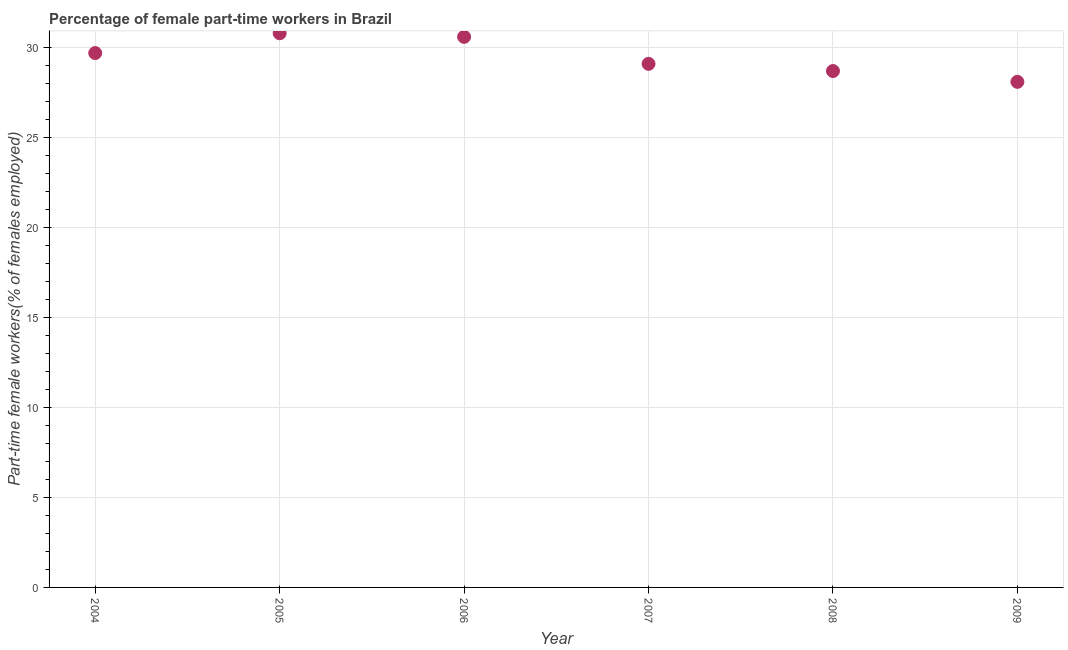What is the percentage of part-time female workers in 2009?
Provide a succinct answer. 28.1. Across all years, what is the maximum percentage of part-time female workers?
Ensure brevity in your answer.  30.8. Across all years, what is the minimum percentage of part-time female workers?
Your answer should be very brief. 28.1. In which year was the percentage of part-time female workers minimum?
Ensure brevity in your answer.  2009. What is the sum of the percentage of part-time female workers?
Your answer should be compact. 177. What is the difference between the percentage of part-time female workers in 2004 and 2005?
Offer a very short reply. -1.1. What is the average percentage of part-time female workers per year?
Give a very brief answer. 29.5. What is the median percentage of part-time female workers?
Keep it short and to the point. 29.4. In how many years, is the percentage of part-time female workers greater than 12 %?
Your answer should be very brief. 6. What is the ratio of the percentage of part-time female workers in 2006 to that in 2008?
Give a very brief answer. 1.07. What is the difference between the highest and the second highest percentage of part-time female workers?
Offer a terse response. 0.2. Is the sum of the percentage of part-time female workers in 2004 and 2009 greater than the maximum percentage of part-time female workers across all years?
Give a very brief answer. Yes. What is the difference between the highest and the lowest percentage of part-time female workers?
Provide a succinct answer. 2.7. In how many years, is the percentage of part-time female workers greater than the average percentage of part-time female workers taken over all years?
Offer a very short reply. 3. Does the graph contain any zero values?
Ensure brevity in your answer.  No. Does the graph contain grids?
Your answer should be very brief. Yes. What is the title of the graph?
Offer a terse response. Percentage of female part-time workers in Brazil. What is the label or title of the X-axis?
Your answer should be compact. Year. What is the label or title of the Y-axis?
Provide a succinct answer. Part-time female workers(% of females employed). What is the Part-time female workers(% of females employed) in 2004?
Your response must be concise. 29.7. What is the Part-time female workers(% of females employed) in 2005?
Provide a short and direct response. 30.8. What is the Part-time female workers(% of females employed) in 2006?
Offer a terse response. 30.6. What is the Part-time female workers(% of females employed) in 2007?
Give a very brief answer. 29.1. What is the Part-time female workers(% of females employed) in 2008?
Your response must be concise. 28.7. What is the Part-time female workers(% of females employed) in 2009?
Make the answer very short. 28.1. What is the difference between the Part-time female workers(% of females employed) in 2004 and 2005?
Provide a succinct answer. -1.1. What is the difference between the Part-time female workers(% of females employed) in 2004 and 2006?
Ensure brevity in your answer.  -0.9. What is the difference between the Part-time female workers(% of females employed) in 2004 and 2007?
Ensure brevity in your answer.  0.6. What is the difference between the Part-time female workers(% of females employed) in 2005 and 2007?
Provide a short and direct response. 1.7. What is the difference between the Part-time female workers(% of females employed) in 2007 and 2008?
Provide a succinct answer. 0.4. What is the difference between the Part-time female workers(% of females employed) in 2007 and 2009?
Provide a succinct answer. 1. What is the ratio of the Part-time female workers(% of females employed) in 2004 to that in 2005?
Your answer should be very brief. 0.96. What is the ratio of the Part-time female workers(% of females employed) in 2004 to that in 2008?
Keep it short and to the point. 1.03. What is the ratio of the Part-time female workers(% of females employed) in 2004 to that in 2009?
Make the answer very short. 1.06. What is the ratio of the Part-time female workers(% of females employed) in 2005 to that in 2007?
Keep it short and to the point. 1.06. What is the ratio of the Part-time female workers(% of females employed) in 2005 to that in 2008?
Provide a short and direct response. 1.07. What is the ratio of the Part-time female workers(% of females employed) in 2005 to that in 2009?
Offer a terse response. 1.1. What is the ratio of the Part-time female workers(% of females employed) in 2006 to that in 2007?
Your answer should be very brief. 1.05. What is the ratio of the Part-time female workers(% of females employed) in 2006 to that in 2008?
Offer a terse response. 1.07. What is the ratio of the Part-time female workers(% of females employed) in 2006 to that in 2009?
Keep it short and to the point. 1.09. What is the ratio of the Part-time female workers(% of females employed) in 2007 to that in 2009?
Your answer should be compact. 1.04. What is the ratio of the Part-time female workers(% of females employed) in 2008 to that in 2009?
Your answer should be very brief. 1.02. 